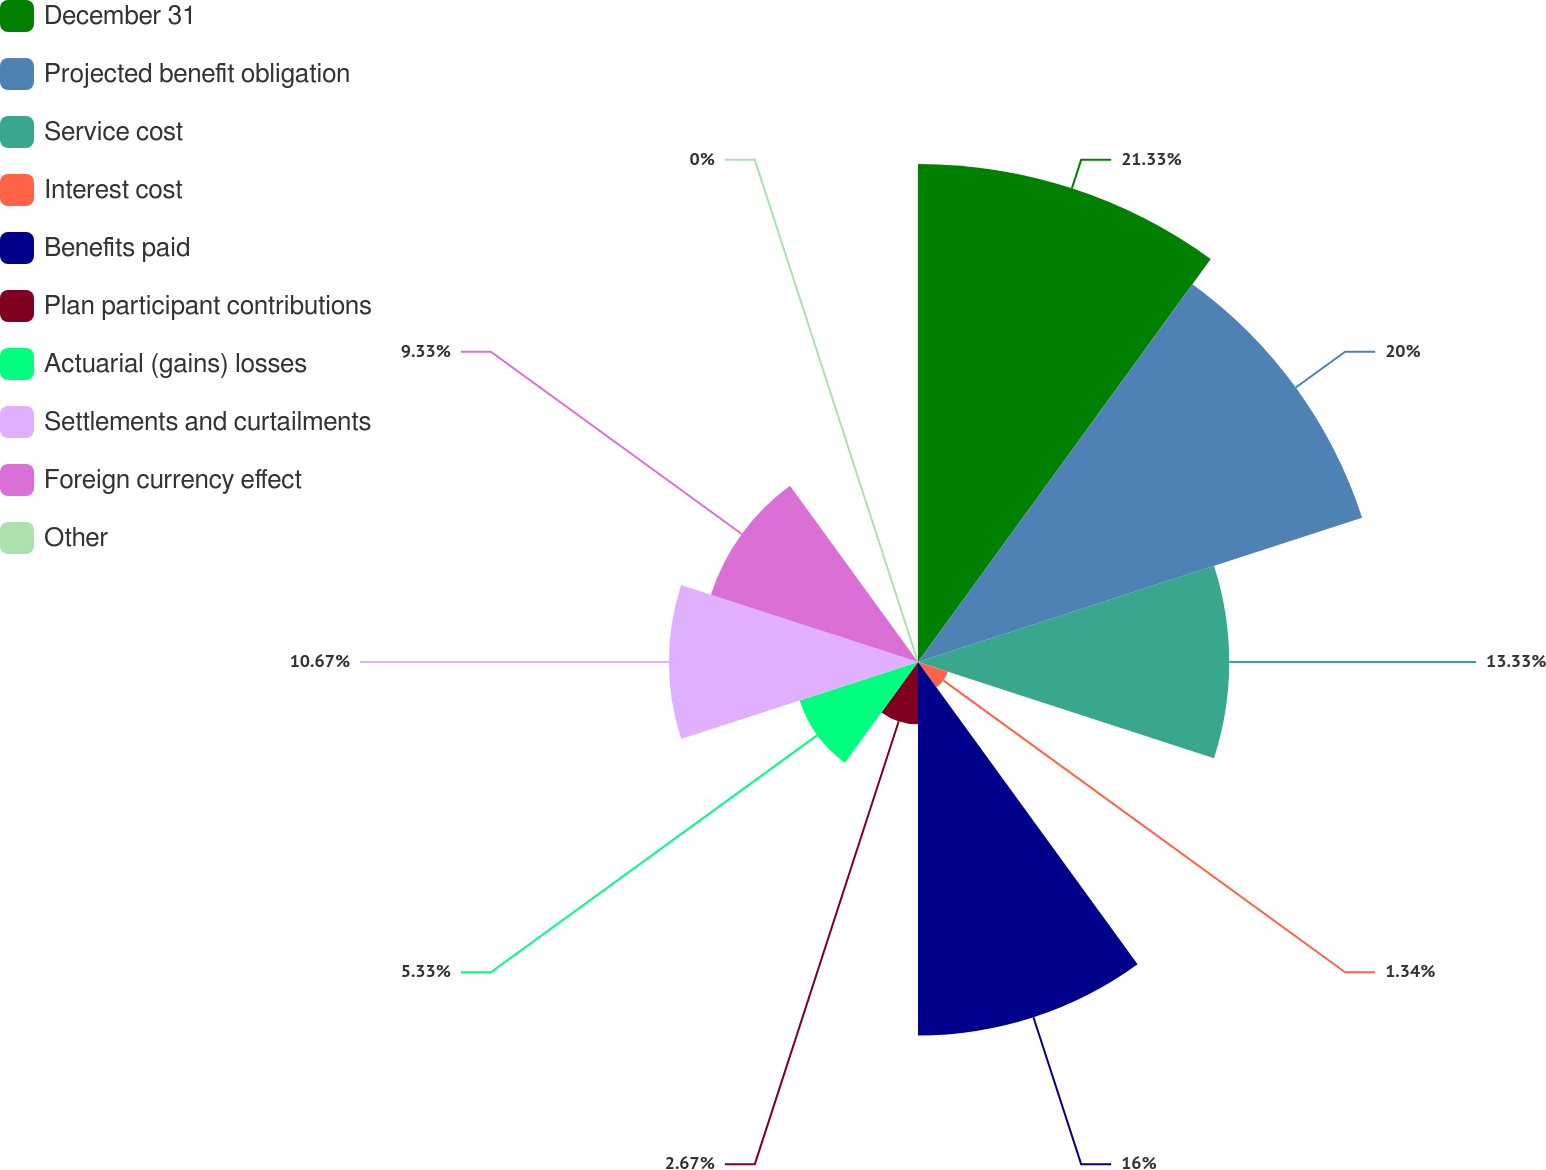Convert chart to OTSL. <chart><loc_0><loc_0><loc_500><loc_500><pie_chart><fcel>December 31<fcel>Projected benefit obligation<fcel>Service cost<fcel>Interest cost<fcel>Benefits paid<fcel>Plan participant contributions<fcel>Actuarial (gains) losses<fcel>Settlements and curtailments<fcel>Foreign currency effect<fcel>Other<nl><fcel>21.33%<fcel>20.0%<fcel>13.33%<fcel>1.34%<fcel>16.0%<fcel>2.67%<fcel>5.33%<fcel>10.67%<fcel>9.33%<fcel>0.0%<nl></chart> 